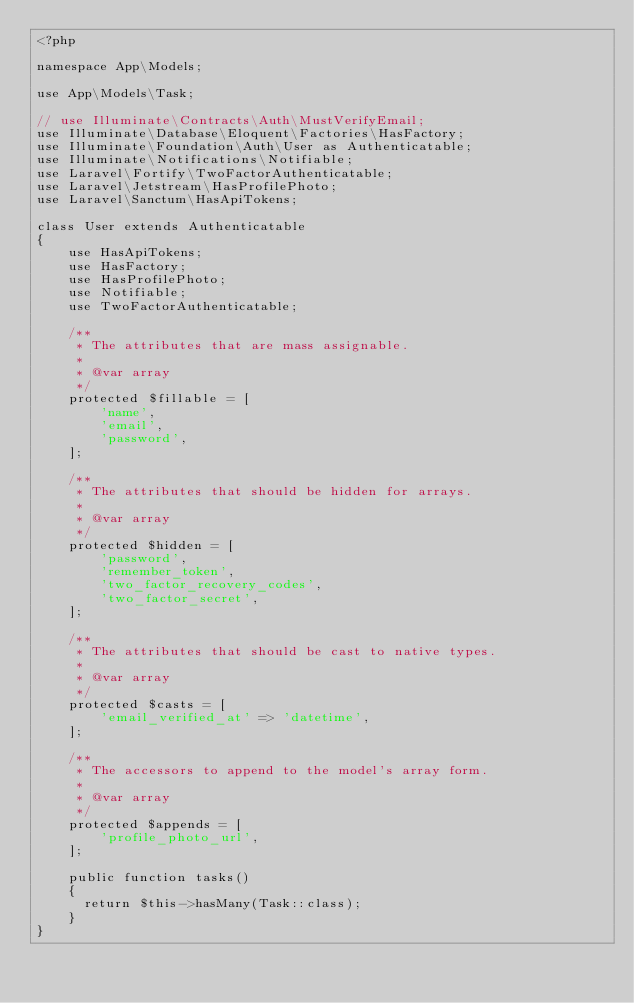<code> <loc_0><loc_0><loc_500><loc_500><_PHP_><?php

namespace App\Models;

use App\Models\Task;

// use Illuminate\Contracts\Auth\MustVerifyEmail;
use Illuminate\Database\Eloquent\Factories\HasFactory;
use Illuminate\Foundation\Auth\User as Authenticatable;
use Illuminate\Notifications\Notifiable;
use Laravel\Fortify\TwoFactorAuthenticatable;
use Laravel\Jetstream\HasProfilePhoto;
use Laravel\Sanctum\HasApiTokens;

class User extends Authenticatable
{
    use HasApiTokens;
    use HasFactory;
    use HasProfilePhoto;
    use Notifiable;
    use TwoFactorAuthenticatable;

    /**
     * The attributes that are mass assignable.
     *
     * @var array
     */
    protected $fillable = [
        'name',
        'email',
        'password',
    ];

    /**
     * The attributes that should be hidden for arrays.
     *
     * @var array
     */
    protected $hidden = [
        'password',
        'remember_token',
        'two_factor_recovery_codes',
        'two_factor_secret',
    ];

    /**
     * The attributes that should be cast to native types.
     *
     * @var array
     */
    protected $casts = [
        'email_verified_at' => 'datetime',
    ];

    /**
     * The accessors to append to the model's array form.
     *
     * @var array
     */
    protected $appends = [
        'profile_photo_url',
    ];

    public function tasks()
    {
    	return $this->hasMany(Task::class);
    }
}
</code> 